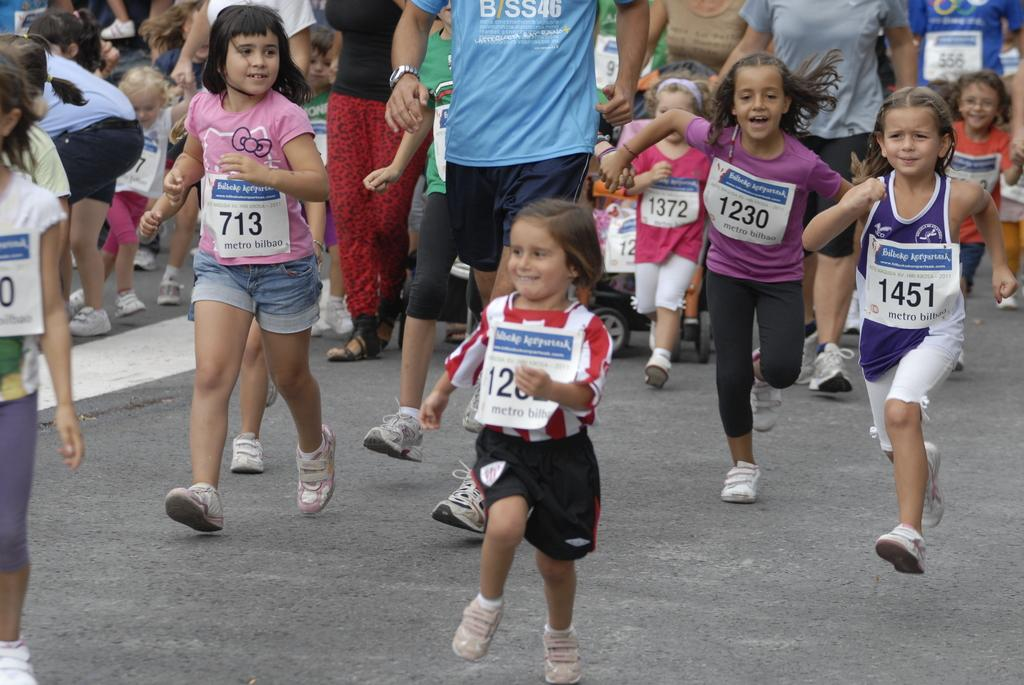<image>
Summarize the visual content of the image. A girl is running in a pink shirt with the number 713 on it. 